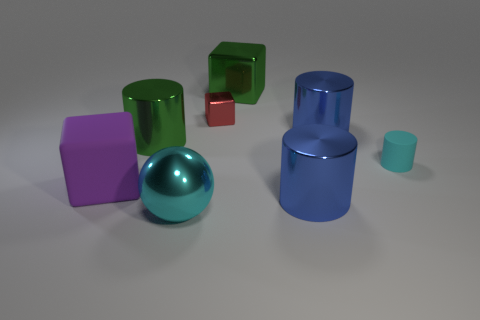There is a thing that is the same color as the tiny cylinder; what is its size?
Your answer should be compact. Large. The large thing that is the same color as the matte cylinder is what shape?
Ensure brevity in your answer.  Sphere. Do the big shiny sphere that is left of the tiny cyan matte object and the rubber cylinder have the same color?
Offer a terse response. Yes. There is a cyan object that is behind the rubber block; what is it made of?
Make the answer very short. Rubber. There is a green shiny cylinder; are there any big purple objects behind it?
Provide a succinct answer. No. Is there a shiny thing of the same color as the small cylinder?
Your answer should be very brief. Yes. How many big objects are yellow metallic cylinders or blocks?
Provide a succinct answer. 2. Is the material of the large cylinder that is left of the red metal object the same as the red thing?
Keep it short and to the point. Yes. What shape is the large green shiny object that is in front of the green cube that is behind the big blue cylinder that is behind the green cylinder?
Ensure brevity in your answer.  Cylinder. How many purple things are either big rubber blocks or tiny cylinders?
Provide a short and direct response. 1. 